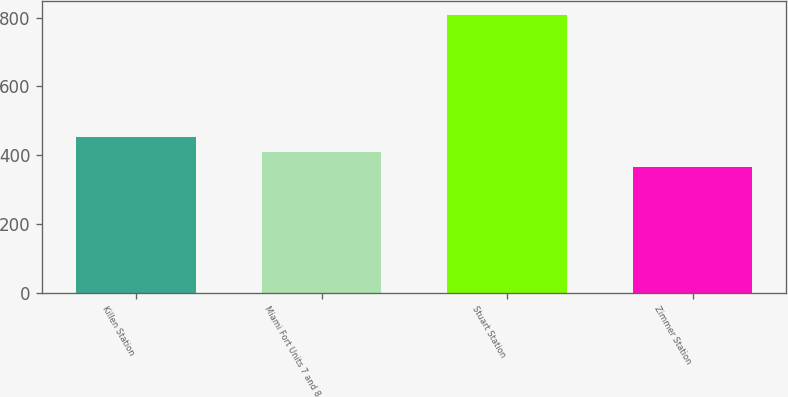Convert chart. <chart><loc_0><loc_0><loc_500><loc_500><bar_chart><fcel>Killen Station<fcel>Miami Fort Units 7 and 8<fcel>Stuart Station<fcel>Zimmer Station<nl><fcel>453.6<fcel>409.3<fcel>808<fcel>365<nl></chart> 